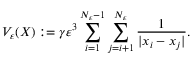<formula> <loc_0><loc_0><loc_500><loc_500>V _ { \varepsilon } ( X ) \colon = \gamma \varepsilon ^ { 3 } \sum _ { i = 1 } ^ { N _ { \varepsilon } - 1 } \sum _ { j = i + 1 } ^ { N _ { \varepsilon } } { \frac { 1 } { | x _ { i } - x _ { j } | } } .</formula> 